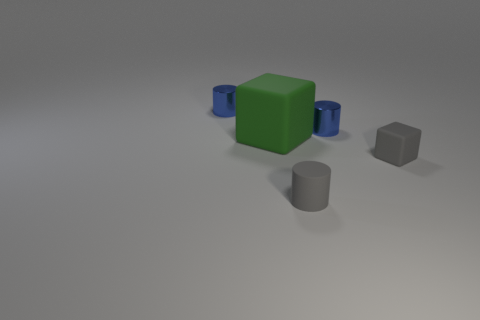Add 2 small blue objects. How many objects exist? 7 Subtract all cubes. How many objects are left? 3 Add 4 big purple things. How many big purple things exist? 4 Subtract 1 gray cylinders. How many objects are left? 4 Subtract all matte blocks. Subtract all rubber things. How many objects are left? 0 Add 4 tiny gray rubber things. How many tiny gray rubber things are left? 6 